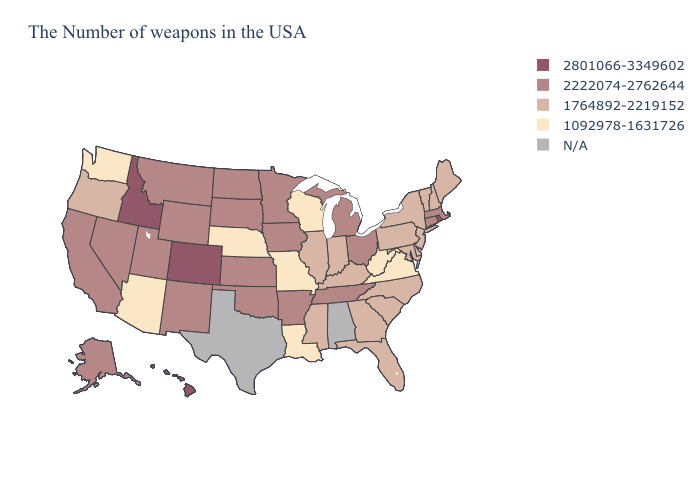Which states have the highest value in the USA?
Write a very short answer. Rhode Island, Colorado, Idaho, Hawaii. Name the states that have a value in the range 1092978-1631726?
Quick response, please. Virginia, West Virginia, Wisconsin, Louisiana, Missouri, Nebraska, Arizona, Washington. Name the states that have a value in the range 1764892-2219152?
Give a very brief answer. Maine, New Hampshire, Vermont, New York, New Jersey, Delaware, Maryland, Pennsylvania, North Carolina, South Carolina, Florida, Georgia, Kentucky, Indiana, Illinois, Mississippi, Oregon. Does Colorado have the highest value in the USA?
Write a very short answer. Yes. Name the states that have a value in the range 2222074-2762644?
Give a very brief answer. Massachusetts, Connecticut, Ohio, Michigan, Tennessee, Arkansas, Minnesota, Iowa, Kansas, Oklahoma, South Dakota, North Dakota, Wyoming, New Mexico, Utah, Montana, Nevada, California, Alaska. Which states have the lowest value in the USA?
Keep it brief. Virginia, West Virginia, Wisconsin, Louisiana, Missouri, Nebraska, Arizona, Washington. Name the states that have a value in the range 2801066-3349602?
Quick response, please. Rhode Island, Colorado, Idaho, Hawaii. What is the value of Wyoming?
Write a very short answer. 2222074-2762644. Among the states that border Pennsylvania , which have the highest value?
Keep it brief. Ohio. What is the value of Maine?
Give a very brief answer. 1764892-2219152. Name the states that have a value in the range 2801066-3349602?
Be succinct. Rhode Island, Colorado, Idaho, Hawaii. Does Idaho have the highest value in the USA?
Keep it brief. Yes. Does Ohio have the highest value in the USA?
Quick response, please. No. Does Hawaii have the highest value in the USA?
Concise answer only. Yes. How many symbols are there in the legend?
Be succinct. 5. 